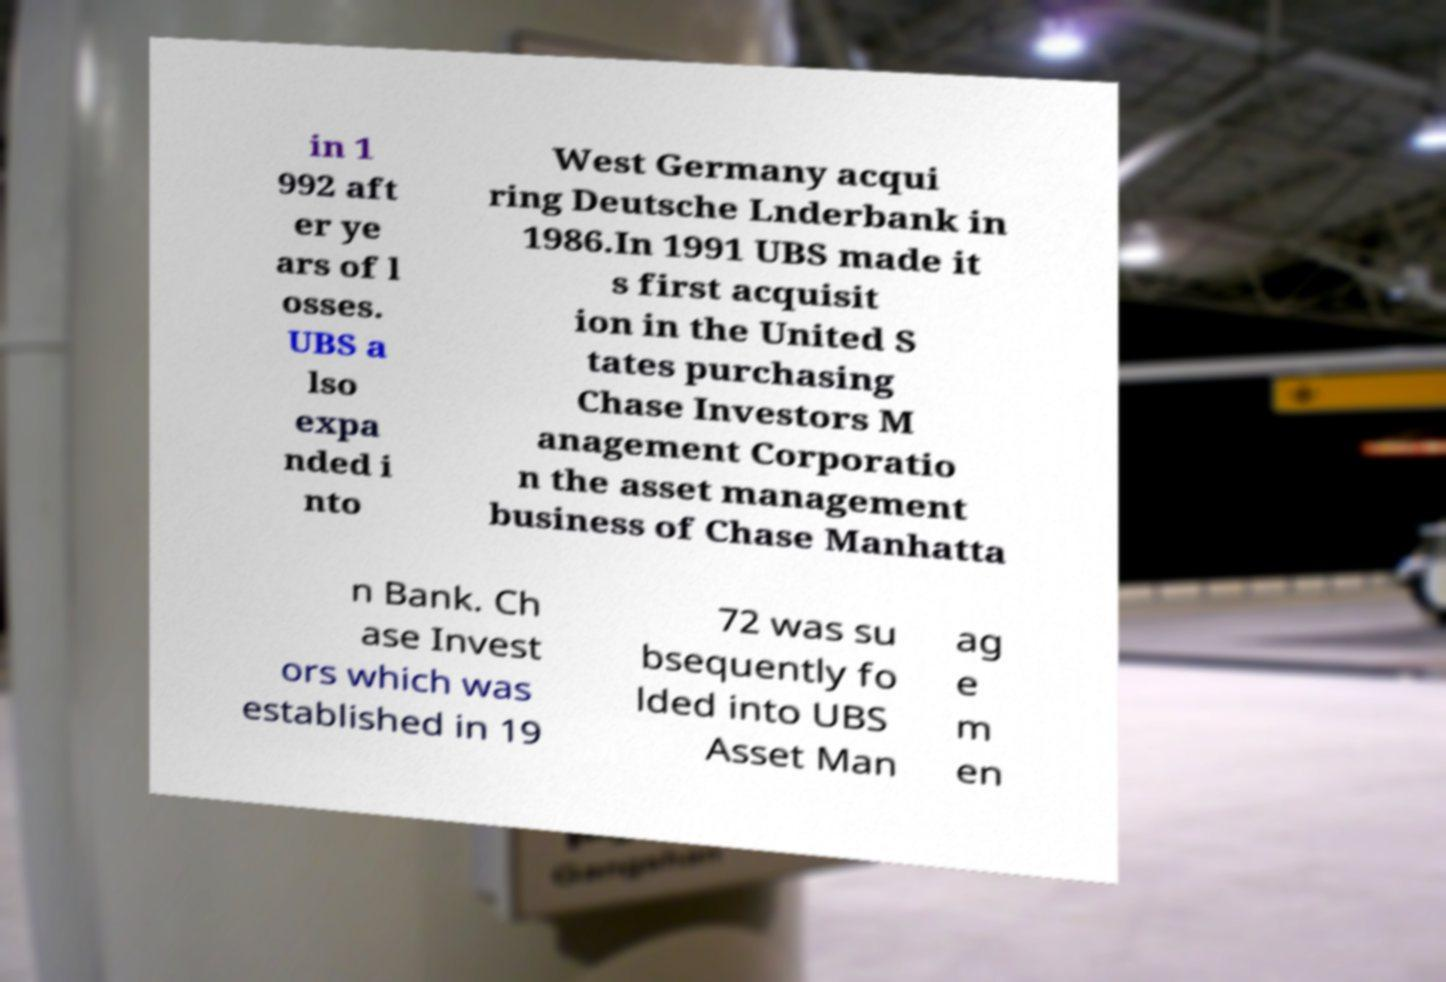What messages or text are displayed in this image? I need them in a readable, typed format. in 1 992 aft er ye ars of l osses. UBS a lso expa nded i nto West Germany acqui ring Deutsche Lnderbank in 1986.In 1991 UBS made it s first acquisit ion in the United S tates purchasing Chase Investors M anagement Corporatio n the asset management business of Chase Manhatta n Bank. Ch ase Invest ors which was established in 19 72 was su bsequently fo lded into UBS Asset Man ag e m en 